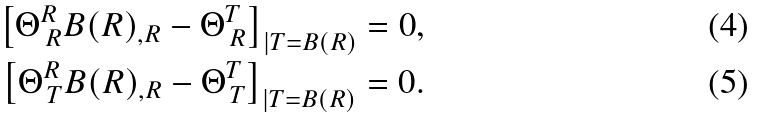Convert formula to latex. <formula><loc_0><loc_0><loc_500><loc_500>\left [ \Theta ^ { R } _ { \, R } B ( R ) _ { , R } - \Theta ^ { T } _ { \, R } \right ] _ { | T = B ( R ) } = 0 , \\ \left [ \Theta ^ { R } _ { \, T } B ( R ) _ { , R } - \Theta ^ { T } _ { \, T } \right ] _ { | T = B ( R ) } = 0 .</formula> 